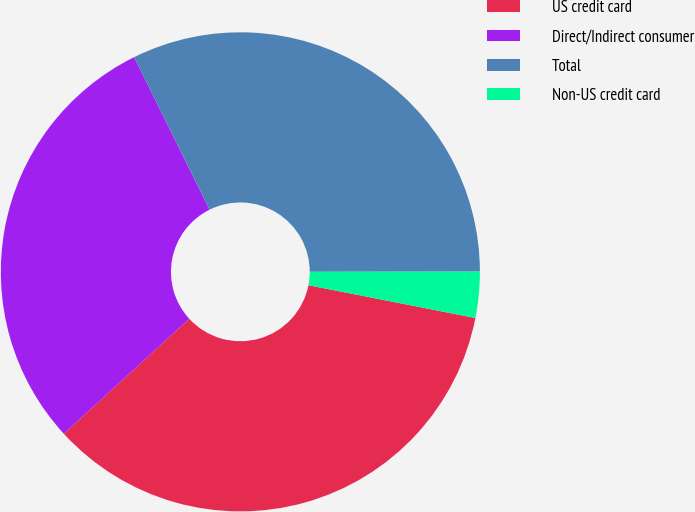Convert chart to OTSL. <chart><loc_0><loc_0><loc_500><loc_500><pie_chart><fcel>US credit card<fcel>Direct/Indirect consumer<fcel>Total<fcel>Non-US credit card<nl><fcel>35.1%<fcel>29.5%<fcel>32.3%<fcel>3.1%<nl></chart> 